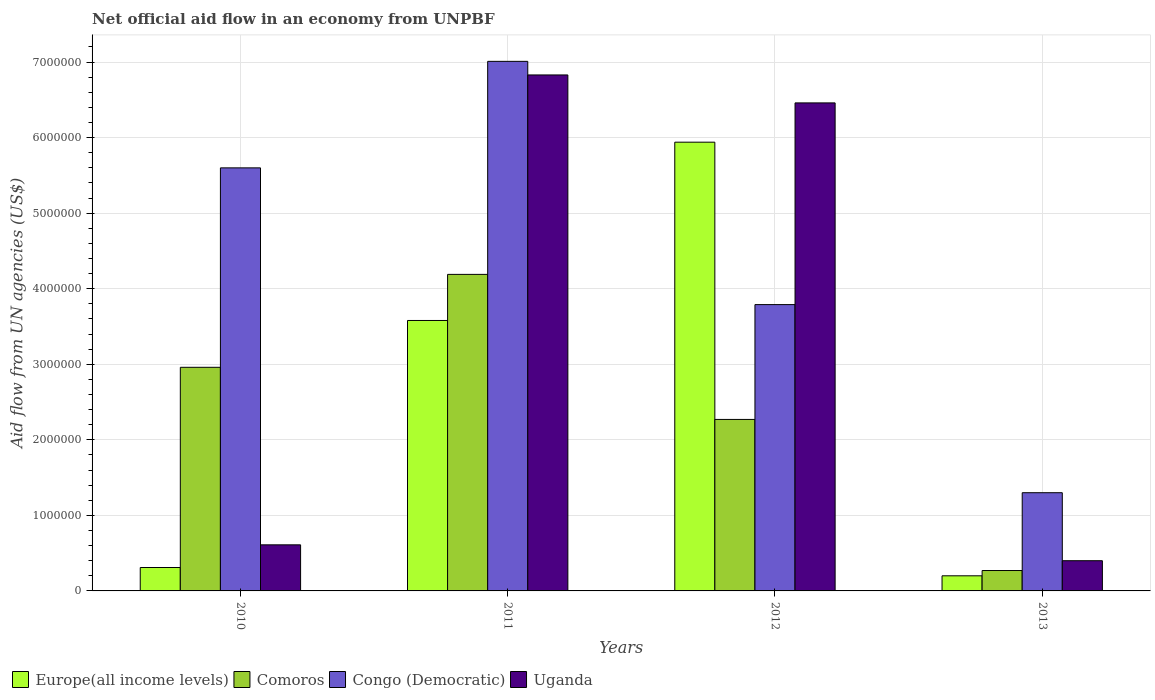Are the number of bars on each tick of the X-axis equal?
Offer a terse response. Yes. How many bars are there on the 3rd tick from the left?
Make the answer very short. 4. How many bars are there on the 3rd tick from the right?
Provide a short and direct response. 4. What is the label of the 3rd group of bars from the left?
Your answer should be compact. 2012. In how many cases, is the number of bars for a given year not equal to the number of legend labels?
Keep it short and to the point. 0. What is the net official aid flow in Congo (Democratic) in 2011?
Provide a short and direct response. 7.01e+06. Across all years, what is the maximum net official aid flow in Europe(all income levels)?
Give a very brief answer. 5.94e+06. In which year was the net official aid flow in Europe(all income levels) maximum?
Make the answer very short. 2012. In which year was the net official aid flow in Uganda minimum?
Your answer should be compact. 2013. What is the total net official aid flow in Comoros in the graph?
Keep it short and to the point. 9.69e+06. What is the difference between the net official aid flow in Uganda in 2010 and that in 2012?
Your answer should be compact. -5.85e+06. What is the difference between the net official aid flow in Uganda in 2011 and the net official aid flow in Europe(all income levels) in 2013?
Provide a succinct answer. 6.63e+06. What is the average net official aid flow in Europe(all income levels) per year?
Your answer should be very brief. 2.51e+06. In the year 2010, what is the difference between the net official aid flow in Europe(all income levels) and net official aid flow in Congo (Democratic)?
Offer a terse response. -5.29e+06. In how many years, is the net official aid flow in Europe(all income levels) greater than 4400000 US$?
Give a very brief answer. 1. What is the ratio of the net official aid flow in Congo (Democratic) in 2010 to that in 2011?
Your response must be concise. 0.8. What is the difference between the highest and the second highest net official aid flow in Europe(all income levels)?
Your answer should be very brief. 2.36e+06. What is the difference between the highest and the lowest net official aid flow in Uganda?
Ensure brevity in your answer.  6.43e+06. Is the sum of the net official aid flow in Congo (Democratic) in 2010 and 2012 greater than the maximum net official aid flow in Europe(all income levels) across all years?
Offer a terse response. Yes. What does the 2nd bar from the left in 2013 represents?
Your answer should be very brief. Comoros. What does the 3rd bar from the right in 2012 represents?
Offer a very short reply. Comoros. Is it the case that in every year, the sum of the net official aid flow in Congo (Democratic) and net official aid flow in Europe(all income levels) is greater than the net official aid flow in Uganda?
Keep it short and to the point. Yes. Are all the bars in the graph horizontal?
Keep it short and to the point. No. How many years are there in the graph?
Your answer should be compact. 4. Does the graph contain any zero values?
Provide a short and direct response. No. Where does the legend appear in the graph?
Your answer should be very brief. Bottom left. How many legend labels are there?
Your answer should be very brief. 4. How are the legend labels stacked?
Provide a short and direct response. Horizontal. What is the title of the graph?
Offer a very short reply. Net official aid flow in an economy from UNPBF. Does "Nicaragua" appear as one of the legend labels in the graph?
Provide a succinct answer. No. What is the label or title of the Y-axis?
Provide a succinct answer. Aid flow from UN agencies (US$). What is the Aid flow from UN agencies (US$) in Comoros in 2010?
Provide a succinct answer. 2.96e+06. What is the Aid flow from UN agencies (US$) of Congo (Democratic) in 2010?
Offer a terse response. 5.60e+06. What is the Aid flow from UN agencies (US$) of Uganda in 2010?
Your response must be concise. 6.10e+05. What is the Aid flow from UN agencies (US$) in Europe(all income levels) in 2011?
Make the answer very short. 3.58e+06. What is the Aid flow from UN agencies (US$) of Comoros in 2011?
Your answer should be compact. 4.19e+06. What is the Aid flow from UN agencies (US$) in Congo (Democratic) in 2011?
Make the answer very short. 7.01e+06. What is the Aid flow from UN agencies (US$) of Uganda in 2011?
Your answer should be compact. 6.83e+06. What is the Aid flow from UN agencies (US$) of Europe(all income levels) in 2012?
Your answer should be compact. 5.94e+06. What is the Aid flow from UN agencies (US$) in Comoros in 2012?
Ensure brevity in your answer.  2.27e+06. What is the Aid flow from UN agencies (US$) of Congo (Democratic) in 2012?
Provide a succinct answer. 3.79e+06. What is the Aid flow from UN agencies (US$) of Uganda in 2012?
Offer a terse response. 6.46e+06. What is the Aid flow from UN agencies (US$) in Europe(all income levels) in 2013?
Your response must be concise. 2.00e+05. What is the Aid flow from UN agencies (US$) in Congo (Democratic) in 2013?
Provide a short and direct response. 1.30e+06. What is the Aid flow from UN agencies (US$) of Uganda in 2013?
Offer a very short reply. 4.00e+05. Across all years, what is the maximum Aid flow from UN agencies (US$) in Europe(all income levels)?
Offer a terse response. 5.94e+06. Across all years, what is the maximum Aid flow from UN agencies (US$) in Comoros?
Provide a short and direct response. 4.19e+06. Across all years, what is the maximum Aid flow from UN agencies (US$) of Congo (Democratic)?
Provide a short and direct response. 7.01e+06. Across all years, what is the maximum Aid flow from UN agencies (US$) in Uganda?
Keep it short and to the point. 6.83e+06. Across all years, what is the minimum Aid flow from UN agencies (US$) in Comoros?
Your answer should be very brief. 2.70e+05. Across all years, what is the minimum Aid flow from UN agencies (US$) of Congo (Democratic)?
Your answer should be very brief. 1.30e+06. Across all years, what is the minimum Aid flow from UN agencies (US$) of Uganda?
Your answer should be compact. 4.00e+05. What is the total Aid flow from UN agencies (US$) of Europe(all income levels) in the graph?
Provide a short and direct response. 1.00e+07. What is the total Aid flow from UN agencies (US$) of Comoros in the graph?
Make the answer very short. 9.69e+06. What is the total Aid flow from UN agencies (US$) in Congo (Democratic) in the graph?
Your answer should be very brief. 1.77e+07. What is the total Aid flow from UN agencies (US$) in Uganda in the graph?
Your answer should be very brief. 1.43e+07. What is the difference between the Aid flow from UN agencies (US$) of Europe(all income levels) in 2010 and that in 2011?
Your response must be concise. -3.27e+06. What is the difference between the Aid flow from UN agencies (US$) in Comoros in 2010 and that in 2011?
Give a very brief answer. -1.23e+06. What is the difference between the Aid flow from UN agencies (US$) in Congo (Democratic) in 2010 and that in 2011?
Your response must be concise. -1.41e+06. What is the difference between the Aid flow from UN agencies (US$) of Uganda in 2010 and that in 2011?
Offer a terse response. -6.22e+06. What is the difference between the Aid flow from UN agencies (US$) of Europe(all income levels) in 2010 and that in 2012?
Ensure brevity in your answer.  -5.63e+06. What is the difference between the Aid flow from UN agencies (US$) in Comoros in 2010 and that in 2012?
Offer a very short reply. 6.90e+05. What is the difference between the Aid flow from UN agencies (US$) of Congo (Democratic) in 2010 and that in 2012?
Give a very brief answer. 1.81e+06. What is the difference between the Aid flow from UN agencies (US$) in Uganda in 2010 and that in 2012?
Your answer should be very brief. -5.85e+06. What is the difference between the Aid flow from UN agencies (US$) in Comoros in 2010 and that in 2013?
Your answer should be compact. 2.69e+06. What is the difference between the Aid flow from UN agencies (US$) of Congo (Democratic) in 2010 and that in 2013?
Make the answer very short. 4.30e+06. What is the difference between the Aid flow from UN agencies (US$) in Uganda in 2010 and that in 2013?
Give a very brief answer. 2.10e+05. What is the difference between the Aid flow from UN agencies (US$) in Europe(all income levels) in 2011 and that in 2012?
Keep it short and to the point. -2.36e+06. What is the difference between the Aid flow from UN agencies (US$) of Comoros in 2011 and that in 2012?
Your response must be concise. 1.92e+06. What is the difference between the Aid flow from UN agencies (US$) in Congo (Democratic) in 2011 and that in 2012?
Your answer should be compact. 3.22e+06. What is the difference between the Aid flow from UN agencies (US$) of Europe(all income levels) in 2011 and that in 2013?
Provide a short and direct response. 3.38e+06. What is the difference between the Aid flow from UN agencies (US$) in Comoros in 2011 and that in 2013?
Make the answer very short. 3.92e+06. What is the difference between the Aid flow from UN agencies (US$) of Congo (Democratic) in 2011 and that in 2013?
Provide a short and direct response. 5.71e+06. What is the difference between the Aid flow from UN agencies (US$) of Uganda in 2011 and that in 2013?
Make the answer very short. 6.43e+06. What is the difference between the Aid flow from UN agencies (US$) of Europe(all income levels) in 2012 and that in 2013?
Keep it short and to the point. 5.74e+06. What is the difference between the Aid flow from UN agencies (US$) of Comoros in 2012 and that in 2013?
Make the answer very short. 2.00e+06. What is the difference between the Aid flow from UN agencies (US$) in Congo (Democratic) in 2012 and that in 2013?
Provide a short and direct response. 2.49e+06. What is the difference between the Aid flow from UN agencies (US$) of Uganda in 2012 and that in 2013?
Provide a short and direct response. 6.06e+06. What is the difference between the Aid flow from UN agencies (US$) of Europe(all income levels) in 2010 and the Aid flow from UN agencies (US$) of Comoros in 2011?
Your answer should be very brief. -3.88e+06. What is the difference between the Aid flow from UN agencies (US$) in Europe(all income levels) in 2010 and the Aid flow from UN agencies (US$) in Congo (Democratic) in 2011?
Offer a terse response. -6.70e+06. What is the difference between the Aid flow from UN agencies (US$) of Europe(all income levels) in 2010 and the Aid flow from UN agencies (US$) of Uganda in 2011?
Your response must be concise. -6.52e+06. What is the difference between the Aid flow from UN agencies (US$) of Comoros in 2010 and the Aid flow from UN agencies (US$) of Congo (Democratic) in 2011?
Make the answer very short. -4.05e+06. What is the difference between the Aid flow from UN agencies (US$) in Comoros in 2010 and the Aid flow from UN agencies (US$) in Uganda in 2011?
Offer a very short reply. -3.87e+06. What is the difference between the Aid flow from UN agencies (US$) of Congo (Democratic) in 2010 and the Aid flow from UN agencies (US$) of Uganda in 2011?
Offer a very short reply. -1.23e+06. What is the difference between the Aid flow from UN agencies (US$) of Europe(all income levels) in 2010 and the Aid flow from UN agencies (US$) of Comoros in 2012?
Your answer should be compact. -1.96e+06. What is the difference between the Aid flow from UN agencies (US$) in Europe(all income levels) in 2010 and the Aid flow from UN agencies (US$) in Congo (Democratic) in 2012?
Ensure brevity in your answer.  -3.48e+06. What is the difference between the Aid flow from UN agencies (US$) in Europe(all income levels) in 2010 and the Aid flow from UN agencies (US$) in Uganda in 2012?
Keep it short and to the point. -6.15e+06. What is the difference between the Aid flow from UN agencies (US$) in Comoros in 2010 and the Aid flow from UN agencies (US$) in Congo (Democratic) in 2012?
Keep it short and to the point. -8.30e+05. What is the difference between the Aid flow from UN agencies (US$) of Comoros in 2010 and the Aid flow from UN agencies (US$) of Uganda in 2012?
Give a very brief answer. -3.50e+06. What is the difference between the Aid flow from UN agencies (US$) in Congo (Democratic) in 2010 and the Aid flow from UN agencies (US$) in Uganda in 2012?
Give a very brief answer. -8.60e+05. What is the difference between the Aid flow from UN agencies (US$) in Europe(all income levels) in 2010 and the Aid flow from UN agencies (US$) in Comoros in 2013?
Make the answer very short. 4.00e+04. What is the difference between the Aid flow from UN agencies (US$) of Europe(all income levels) in 2010 and the Aid flow from UN agencies (US$) of Congo (Democratic) in 2013?
Offer a terse response. -9.90e+05. What is the difference between the Aid flow from UN agencies (US$) in Comoros in 2010 and the Aid flow from UN agencies (US$) in Congo (Democratic) in 2013?
Your response must be concise. 1.66e+06. What is the difference between the Aid flow from UN agencies (US$) of Comoros in 2010 and the Aid flow from UN agencies (US$) of Uganda in 2013?
Provide a succinct answer. 2.56e+06. What is the difference between the Aid flow from UN agencies (US$) of Congo (Democratic) in 2010 and the Aid flow from UN agencies (US$) of Uganda in 2013?
Provide a succinct answer. 5.20e+06. What is the difference between the Aid flow from UN agencies (US$) of Europe(all income levels) in 2011 and the Aid flow from UN agencies (US$) of Comoros in 2012?
Provide a succinct answer. 1.31e+06. What is the difference between the Aid flow from UN agencies (US$) in Europe(all income levels) in 2011 and the Aid flow from UN agencies (US$) in Uganda in 2012?
Your response must be concise. -2.88e+06. What is the difference between the Aid flow from UN agencies (US$) in Comoros in 2011 and the Aid flow from UN agencies (US$) in Uganda in 2012?
Make the answer very short. -2.27e+06. What is the difference between the Aid flow from UN agencies (US$) in Europe(all income levels) in 2011 and the Aid flow from UN agencies (US$) in Comoros in 2013?
Give a very brief answer. 3.31e+06. What is the difference between the Aid flow from UN agencies (US$) of Europe(all income levels) in 2011 and the Aid flow from UN agencies (US$) of Congo (Democratic) in 2013?
Your answer should be compact. 2.28e+06. What is the difference between the Aid flow from UN agencies (US$) of Europe(all income levels) in 2011 and the Aid flow from UN agencies (US$) of Uganda in 2013?
Offer a very short reply. 3.18e+06. What is the difference between the Aid flow from UN agencies (US$) in Comoros in 2011 and the Aid flow from UN agencies (US$) in Congo (Democratic) in 2013?
Your answer should be compact. 2.89e+06. What is the difference between the Aid flow from UN agencies (US$) in Comoros in 2011 and the Aid flow from UN agencies (US$) in Uganda in 2013?
Offer a very short reply. 3.79e+06. What is the difference between the Aid flow from UN agencies (US$) in Congo (Democratic) in 2011 and the Aid flow from UN agencies (US$) in Uganda in 2013?
Your answer should be compact. 6.61e+06. What is the difference between the Aid flow from UN agencies (US$) in Europe(all income levels) in 2012 and the Aid flow from UN agencies (US$) in Comoros in 2013?
Provide a succinct answer. 5.67e+06. What is the difference between the Aid flow from UN agencies (US$) in Europe(all income levels) in 2012 and the Aid flow from UN agencies (US$) in Congo (Democratic) in 2013?
Offer a very short reply. 4.64e+06. What is the difference between the Aid flow from UN agencies (US$) of Europe(all income levels) in 2012 and the Aid flow from UN agencies (US$) of Uganda in 2013?
Give a very brief answer. 5.54e+06. What is the difference between the Aid flow from UN agencies (US$) of Comoros in 2012 and the Aid flow from UN agencies (US$) of Congo (Democratic) in 2013?
Provide a succinct answer. 9.70e+05. What is the difference between the Aid flow from UN agencies (US$) of Comoros in 2012 and the Aid flow from UN agencies (US$) of Uganda in 2013?
Provide a succinct answer. 1.87e+06. What is the difference between the Aid flow from UN agencies (US$) of Congo (Democratic) in 2012 and the Aid flow from UN agencies (US$) of Uganda in 2013?
Your response must be concise. 3.39e+06. What is the average Aid flow from UN agencies (US$) of Europe(all income levels) per year?
Ensure brevity in your answer.  2.51e+06. What is the average Aid flow from UN agencies (US$) of Comoros per year?
Keep it short and to the point. 2.42e+06. What is the average Aid flow from UN agencies (US$) of Congo (Democratic) per year?
Ensure brevity in your answer.  4.42e+06. What is the average Aid flow from UN agencies (US$) of Uganda per year?
Provide a short and direct response. 3.58e+06. In the year 2010, what is the difference between the Aid flow from UN agencies (US$) of Europe(all income levels) and Aid flow from UN agencies (US$) of Comoros?
Make the answer very short. -2.65e+06. In the year 2010, what is the difference between the Aid flow from UN agencies (US$) in Europe(all income levels) and Aid flow from UN agencies (US$) in Congo (Democratic)?
Keep it short and to the point. -5.29e+06. In the year 2010, what is the difference between the Aid flow from UN agencies (US$) in Europe(all income levels) and Aid flow from UN agencies (US$) in Uganda?
Provide a short and direct response. -3.00e+05. In the year 2010, what is the difference between the Aid flow from UN agencies (US$) in Comoros and Aid flow from UN agencies (US$) in Congo (Democratic)?
Your answer should be compact. -2.64e+06. In the year 2010, what is the difference between the Aid flow from UN agencies (US$) of Comoros and Aid flow from UN agencies (US$) of Uganda?
Offer a terse response. 2.35e+06. In the year 2010, what is the difference between the Aid flow from UN agencies (US$) in Congo (Democratic) and Aid flow from UN agencies (US$) in Uganda?
Your response must be concise. 4.99e+06. In the year 2011, what is the difference between the Aid flow from UN agencies (US$) of Europe(all income levels) and Aid flow from UN agencies (US$) of Comoros?
Your answer should be compact. -6.10e+05. In the year 2011, what is the difference between the Aid flow from UN agencies (US$) in Europe(all income levels) and Aid flow from UN agencies (US$) in Congo (Democratic)?
Keep it short and to the point. -3.43e+06. In the year 2011, what is the difference between the Aid flow from UN agencies (US$) of Europe(all income levels) and Aid flow from UN agencies (US$) of Uganda?
Offer a terse response. -3.25e+06. In the year 2011, what is the difference between the Aid flow from UN agencies (US$) of Comoros and Aid flow from UN agencies (US$) of Congo (Democratic)?
Your answer should be compact. -2.82e+06. In the year 2011, what is the difference between the Aid flow from UN agencies (US$) in Comoros and Aid flow from UN agencies (US$) in Uganda?
Ensure brevity in your answer.  -2.64e+06. In the year 2011, what is the difference between the Aid flow from UN agencies (US$) of Congo (Democratic) and Aid flow from UN agencies (US$) of Uganda?
Provide a short and direct response. 1.80e+05. In the year 2012, what is the difference between the Aid flow from UN agencies (US$) of Europe(all income levels) and Aid flow from UN agencies (US$) of Comoros?
Give a very brief answer. 3.67e+06. In the year 2012, what is the difference between the Aid flow from UN agencies (US$) of Europe(all income levels) and Aid flow from UN agencies (US$) of Congo (Democratic)?
Offer a terse response. 2.15e+06. In the year 2012, what is the difference between the Aid flow from UN agencies (US$) of Europe(all income levels) and Aid flow from UN agencies (US$) of Uganda?
Your answer should be very brief. -5.20e+05. In the year 2012, what is the difference between the Aid flow from UN agencies (US$) of Comoros and Aid flow from UN agencies (US$) of Congo (Democratic)?
Keep it short and to the point. -1.52e+06. In the year 2012, what is the difference between the Aid flow from UN agencies (US$) of Comoros and Aid flow from UN agencies (US$) of Uganda?
Your answer should be compact. -4.19e+06. In the year 2012, what is the difference between the Aid flow from UN agencies (US$) of Congo (Democratic) and Aid flow from UN agencies (US$) of Uganda?
Ensure brevity in your answer.  -2.67e+06. In the year 2013, what is the difference between the Aid flow from UN agencies (US$) of Europe(all income levels) and Aid flow from UN agencies (US$) of Comoros?
Offer a terse response. -7.00e+04. In the year 2013, what is the difference between the Aid flow from UN agencies (US$) in Europe(all income levels) and Aid flow from UN agencies (US$) in Congo (Democratic)?
Make the answer very short. -1.10e+06. In the year 2013, what is the difference between the Aid flow from UN agencies (US$) in Comoros and Aid flow from UN agencies (US$) in Congo (Democratic)?
Your answer should be very brief. -1.03e+06. In the year 2013, what is the difference between the Aid flow from UN agencies (US$) in Comoros and Aid flow from UN agencies (US$) in Uganda?
Your answer should be compact. -1.30e+05. In the year 2013, what is the difference between the Aid flow from UN agencies (US$) of Congo (Democratic) and Aid flow from UN agencies (US$) of Uganda?
Offer a terse response. 9.00e+05. What is the ratio of the Aid flow from UN agencies (US$) in Europe(all income levels) in 2010 to that in 2011?
Make the answer very short. 0.09. What is the ratio of the Aid flow from UN agencies (US$) in Comoros in 2010 to that in 2011?
Ensure brevity in your answer.  0.71. What is the ratio of the Aid flow from UN agencies (US$) in Congo (Democratic) in 2010 to that in 2011?
Your response must be concise. 0.8. What is the ratio of the Aid flow from UN agencies (US$) in Uganda in 2010 to that in 2011?
Offer a very short reply. 0.09. What is the ratio of the Aid flow from UN agencies (US$) in Europe(all income levels) in 2010 to that in 2012?
Offer a terse response. 0.05. What is the ratio of the Aid flow from UN agencies (US$) in Comoros in 2010 to that in 2012?
Keep it short and to the point. 1.3. What is the ratio of the Aid flow from UN agencies (US$) of Congo (Democratic) in 2010 to that in 2012?
Your answer should be compact. 1.48. What is the ratio of the Aid flow from UN agencies (US$) in Uganda in 2010 to that in 2012?
Ensure brevity in your answer.  0.09. What is the ratio of the Aid flow from UN agencies (US$) of Europe(all income levels) in 2010 to that in 2013?
Your answer should be compact. 1.55. What is the ratio of the Aid flow from UN agencies (US$) in Comoros in 2010 to that in 2013?
Offer a terse response. 10.96. What is the ratio of the Aid flow from UN agencies (US$) of Congo (Democratic) in 2010 to that in 2013?
Your response must be concise. 4.31. What is the ratio of the Aid flow from UN agencies (US$) in Uganda in 2010 to that in 2013?
Keep it short and to the point. 1.52. What is the ratio of the Aid flow from UN agencies (US$) of Europe(all income levels) in 2011 to that in 2012?
Your answer should be compact. 0.6. What is the ratio of the Aid flow from UN agencies (US$) in Comoros in 2011 to that in 2012?
Provide a short and direct response. 1.85. What is the ratio of the Aid flow from UN agencies (US$) in Congo (Democratic) in 2011 to that in 2012?
Your answer should be very brief. 1.85. What is the ratio of the Aid flow from UN agencies (US$) in Uganda in 2011 to that in 2012?
Your response must be concise. 1.06. What is the ratio of the Aid flow from UN agencies (US$) in Comoros in 2011 to that in 2013?
Provide a succinct answer. 15.52. What is the ratio of the Aid flow from UN agencies (US$) of Congo (Democratic) in 2011 to that in 2013?
Provide a short and direct response. 5.39. What is the ratio of the Aid flow from UN agencies (US$) in Uganda in 2011 to that in 2013?
Your response must be concise. 17.07. What is the ratio of the Aid flow from UN agencies (US$) in Europe(all income levels) in 2012 to that in 2013?
Your answer should be very brief. 29.7. What is the ratio of the Aid flow from UN agencies (US$) in Comoros in 2012 to that in 2013?
Your response must be concise. 8.41. What is the ratio of the Aid flow from UN agencies (US$) of Congo (Democratic) in 2012 to that in 2013?
Your answer should be compact. 2.92. What is the ratio of the Aid flow from UN agencies (US$) of Uganda in 2012 to that in 2013?
Your answer should be very brief. 16.15. What is the difference between the highest and the second highest Aid flow from UN agencies (US$) of Europe(all income levels)?
Provide a succinct answer. 2.36e+06. What is the difference between the highest and the second highest Aid flow from UN agencies (US$) of Comoros?
Give a very brief answer. 1.23e+06. What is the difference between the highest and the second highest Aid flow from UN agencies (US$) in Congo (Democratic)?
Your answer should be very brief. 1.41e+06. What is the difference between the highest and the second highest Aid flow from UN agencies (US$) in Uganda?
Your answer should be compact. 3.70e+05. What is the difference between the highest and the lowest Aid flow from UN agencies (US$) in Europe(all income levels)?
Your answer should be very brief. 5.74e+06. What is the difference between the highest and the lowest Aid flow from UN agencies (US$) in Comoros?
Give a very brief answer. 3.92e+06. What is the difference between the highest and the lowest Aid flow from UN agencies (US$) in Congo (Democratic)?
Give a very brief answer. 5.71e+06. What is the difference between the highest and the lowest Aid flow from UN agencies (US$) in Uganda?
Offer a very short reply. 6.43e+06. 